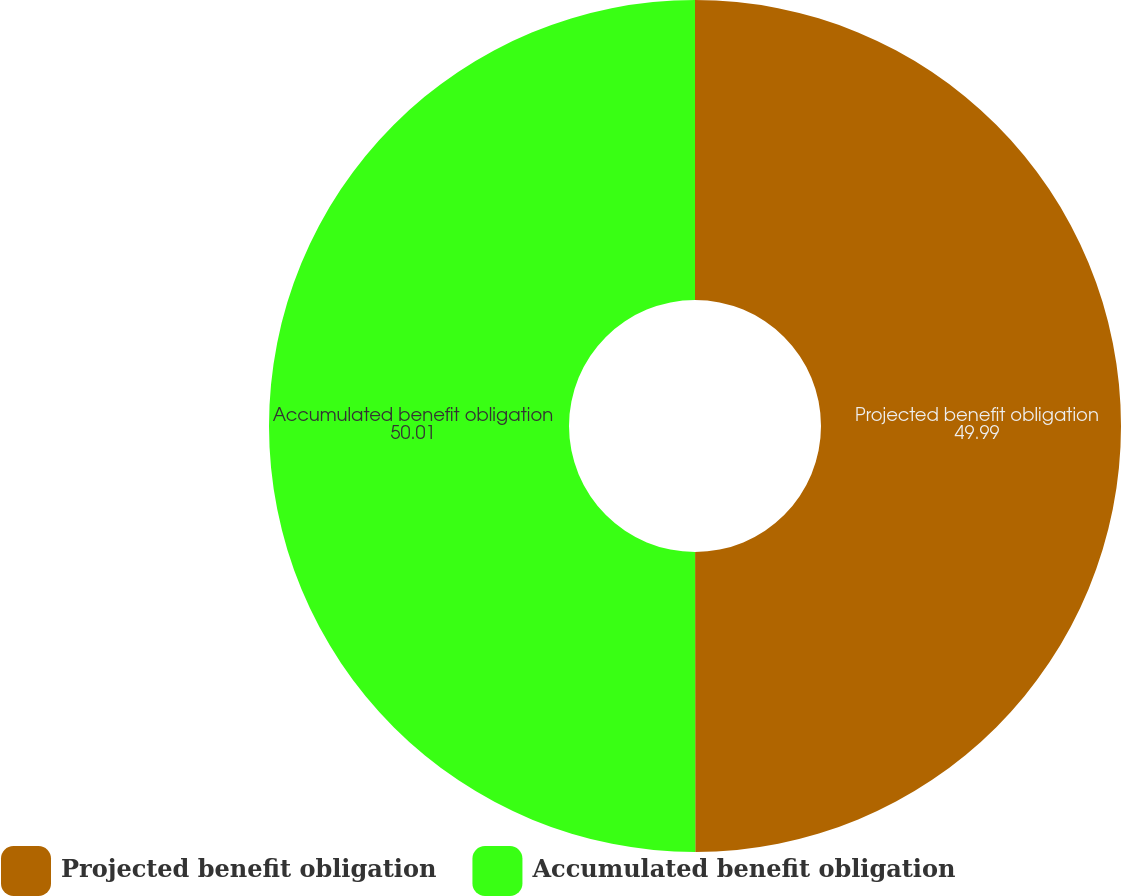<chart> <loc_0><loc_0><loc_500><loc_500><pie_chart><fcel>Projected benefit obligation<fcel>Accumulated benefit obligation<nl><fcel>49.99%<fcel>50.01%<nl></chart> 